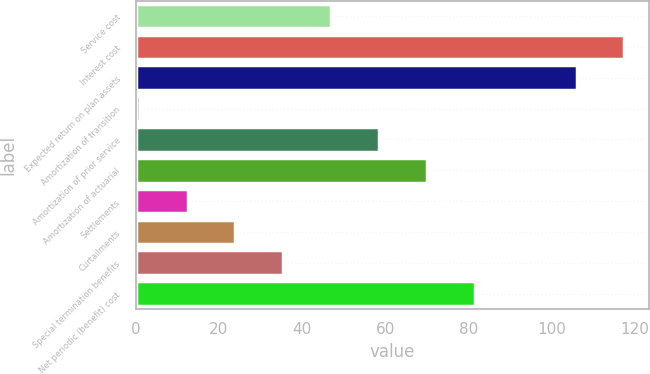Convert chart. <chart><loc_0><loc_0><loc_500><loc_500><bar_chart><fcel>Service cost<fcel>Interest cost<fcel>Expected return on plan assets<fcel>Amortization of transition<fcel>Amortization of prior service<fcel>Amortization of actuarial<fcel>Settlements<fcel>Curtailments<fcel>Special termination benefits<fcel>Net periodic (benefit) cost<nl><fcel>47<fcel>117.5<fcel>106<fcel>1<fcel>58.5<fcel>70<fcel>12.5<fcel>24<fcel>35.5<fcel>81.5<nl></chart> 